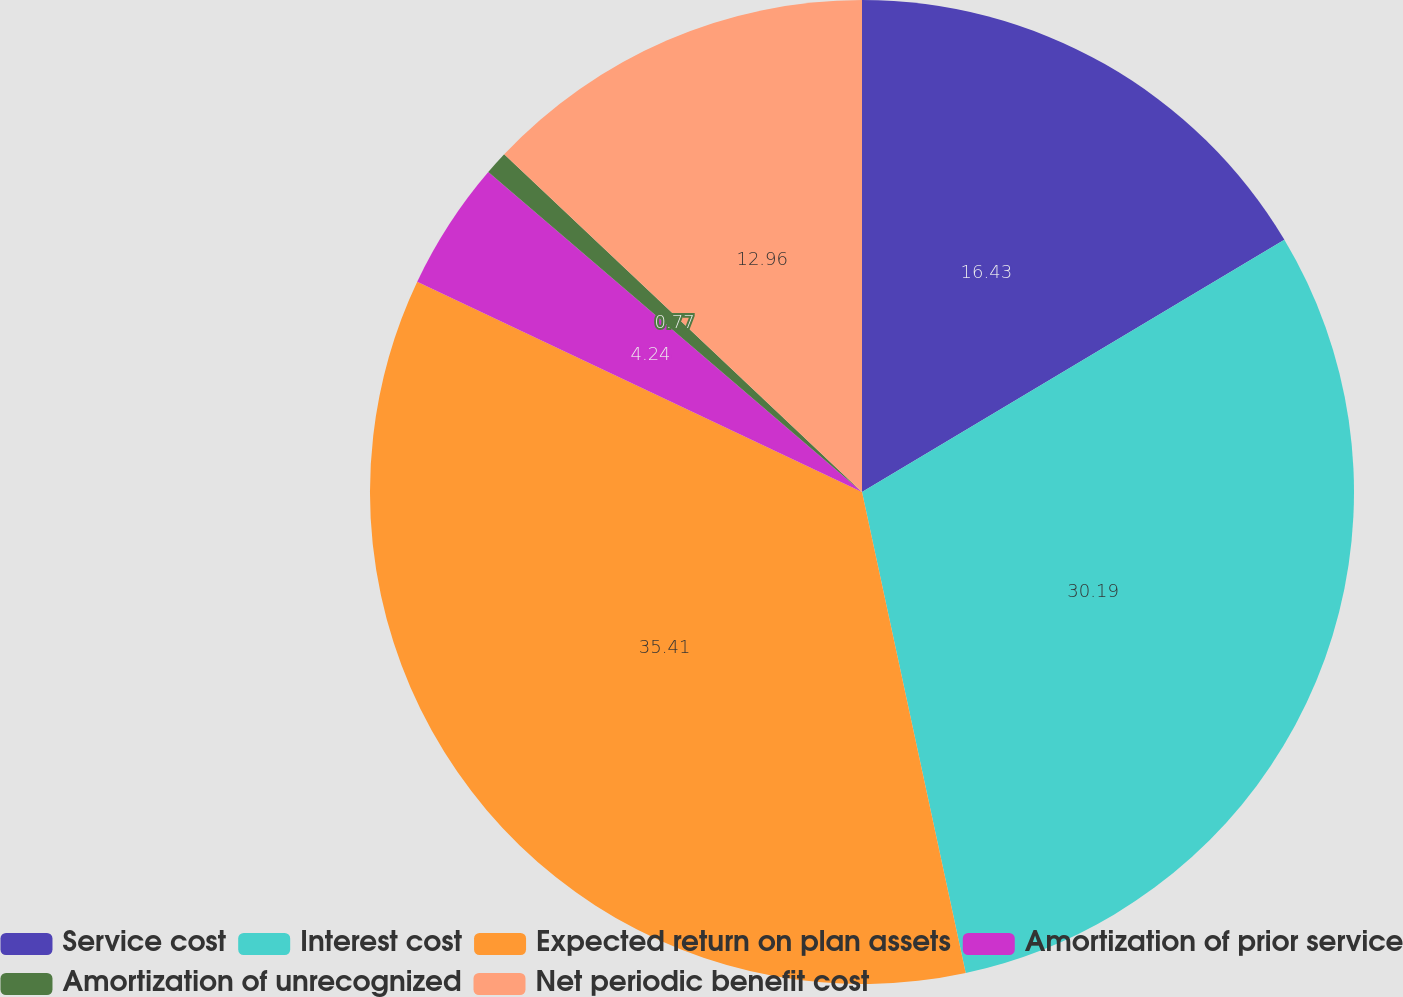Convert chart. <chart><loc_0><loc_0><loc_500><loc_500><pie_chart><fcel>Service cost<fcel>Interest cost<fcel>Expected return on plan assets<fcel>Amortization of prior service<fcel>Amortization of unrecognized<fcel>Net periodic benefit cost<nl><fcel>16.43%<fcel>30.19%<fcel>35.41%<fcel>4.24%<fcel>0.77%<fcel>12.96%<nl></chart> 